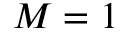Convert formula to latex. <formula><loc_0><loc_0><loc_500><loc_500>M = 1</formula> 